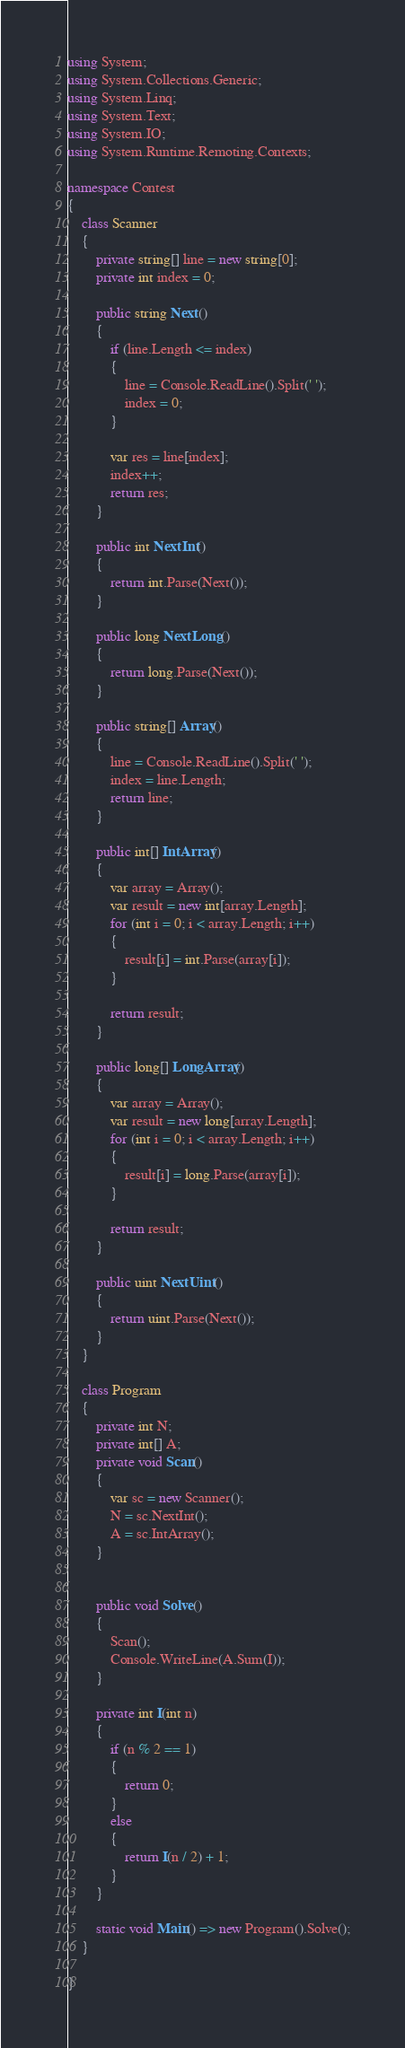Convert code to text. <code><loc_0><loc_0><loc_500><loc_500><_C#_>using System;
using System.Collections.Generic;
using System.Linq;
using System.Text;
using System.IO;
using System.Runtime.Remoting.Contexts;

namespace Contest
{
    class Scanner
    {
        private string[] line = new string[0];
        private int index = 0;

        public string Next()
        {
            if (line.Length <= index)
            {
                line = Console.ReadLine().Split(' ');
                index = 0;
            }

            var res = line[index];
            index++;
            return res;
        }

        public int NextInt()
        {
            return int.Parse(Next());
        }

        public long NextLong()
        {
            return long.Parse(Next());
        }

        public string[] Array()
        {
            line = Console.ReadLine().Split(' ');
            index = line.Length;
            return line;
        }

        public int[] IntArray()
        {
            var array = Array();
            var result = new int[array.Length];
            for (int i = 0; i < array.Length; i++)
            {
                result[i] = int.Parse(array[i]);
            }

            return result;
        }

        public long[] LongArray()
        {
            var array = Array();
            var result = new long[array.Length];
            for (int i = 0; i < array.Length; i++)
            {
                result[i] = long.Parse(array[i]);
            }

            return result;
        }

        public uint NextUint()
        {
            return uint.Parse(Next());
        }
    }

    class Program
    {
        private int N;
        private int[] A;
        private void Scan()
        {
            var sc = new Scanner();
            N = sc.NextInt();
            A = sc.IntArray();
        }


        public void Solve()
        {
            Scan();
            Console.WriteLine(A.Sum(I));
        }

        private int I(int n)
        {
            if (n % 2 == 1)
            {
                return 0;
            }
            else
            {
                return I(n / 2) + 1;
            }
        }

        static void Main() => new Program().Solve();
    }

}
</code> 